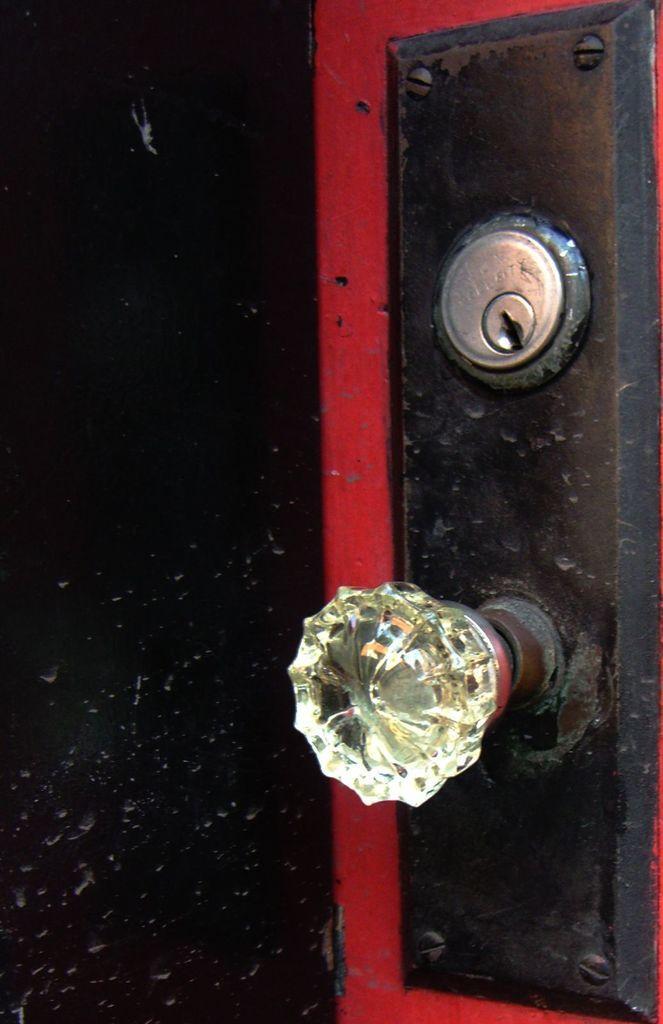Describe this image in one or two sentences. In this picture we can see holder, key panel and black object with red color strips. 